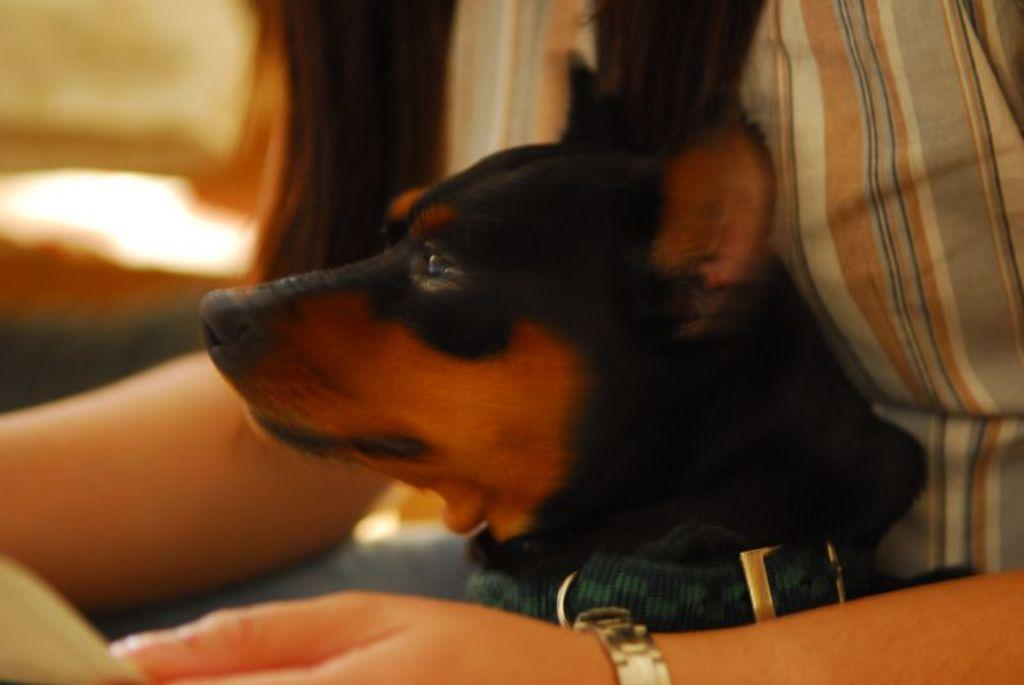Who is present in the image? There is a woman in the image. What other living creature can be seen in the image? There is a dog in the image. What type of boat is visible in the image? There is no boat present in the image; it only features a woman and a dog. How is the distribution of deer in the image? There are no deer present in the image. 